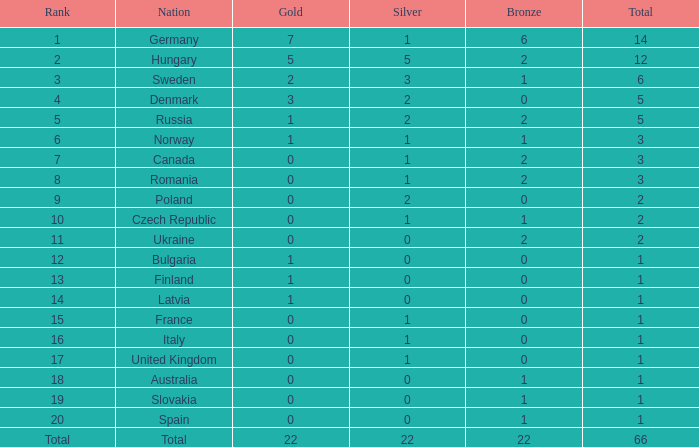What is the fewest number of silver medals won by Canada with fewer than 3 total medals? None. 